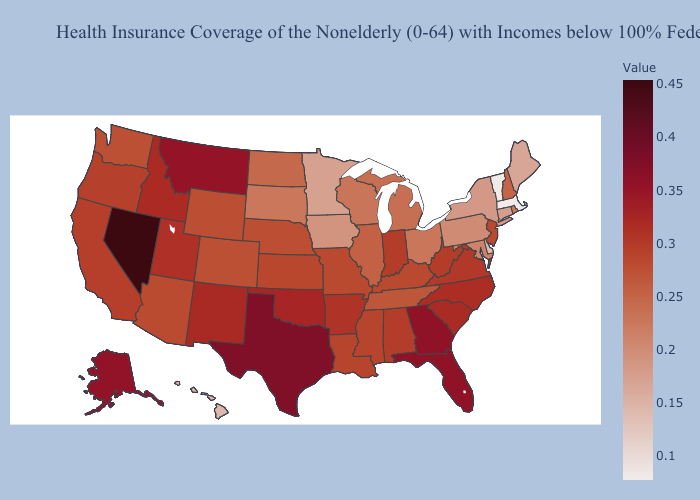Which states have the lowest value in the West?
Concise answer only. Hawaii. Does Pennsylvania have the lowest value in the USA?
Write a very short answer. No. Does South Carolina have a lower value than Georgia?
Keep it brief. Yes. Does the map have missing data?
Quick response, please. No. 